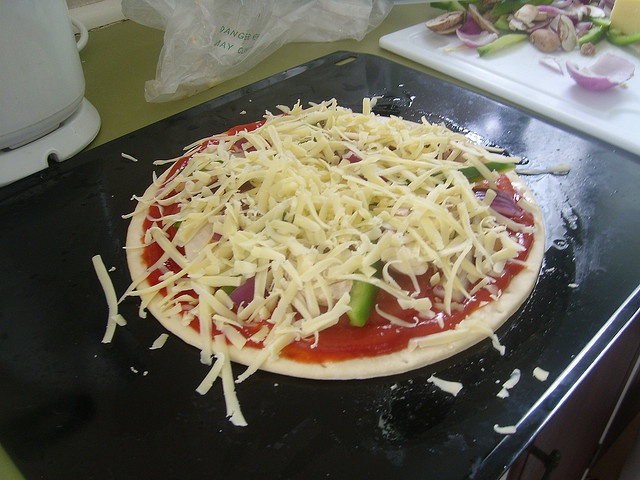Describe the objects in this image and their specific colors. I can see pizza in gray and tan tones and cup in gray tones in this image. 